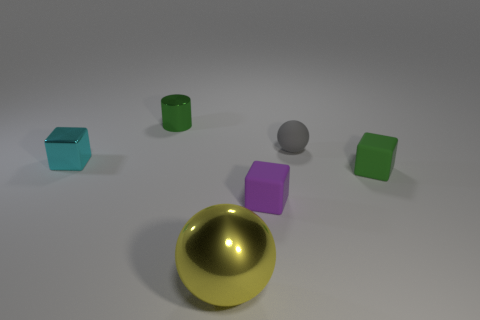What materials are the objects in the image made of? Based on the image's visual qualities, the objects seem to resemble materials such as plastic or metal, which are often used in computer-generated imagery for their smooth and glossy appearance. The gold ball, in particular, suggests a metallic sheen, evocative of polished gold or brass. 